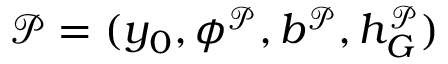<formula> <loc_0><loc_0><loc_500><loc_500>\mathcal { P } = ( y _ { 0 } , \phi ^ { \mathcal { P } } , b ^ { \mathcal { P } } , h _ { G } ^ { \mathcal { P } } )</formula> 